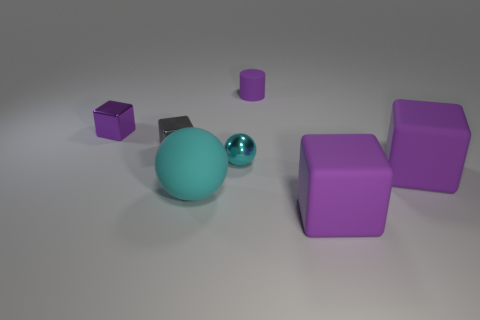Is there anything else that has the same color as the small cylinder?
Your response must be concise. Yes. How many cylinders are there?
Offer a terse response. 1. How many things are balls or purple matte cubes?
Give a very brief answer. 4. There is a shiny object that is the same color as the small matte cylinder; what is its size?
Make the answer very short. Small. There is a tiny cyan object; are there any shiny things behind it?
Provide a succinct answer. Yes. Are there more shiny objects that are in front of the large cyan sphere than gray objects left of the tiny gray shiny thing?
Your response must be concise. No. What is the size of the other shiny object that is the same shape as the gray object?
Offer a terse response. Small. What number of cubes are either large things or large cyan matte things?
Keep it short and to the point. 2. What material is the big thing that is the same color as the tiny ball?
Provide a short and direct response. Rubber. Is the number of gray metal blocks that are behind the gray metal block less than the number of large matte things that are behind the small purple cylinder?
Give a very brief answer. No. 